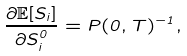Convert formula to latex. <formula><loc_0><loc_0><loc_500><loc_500>\frac { \partial \mathbb { E } [ { S _ { i } } ] } { \partial S _ { i } ^ { 0 } } = P ( 0 , T ) ^ { - 1 } ,</formula> 